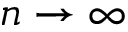<formula> <loc_0><loc_0><loc_500><loc_500>n \rightarrow \infty</formula> 